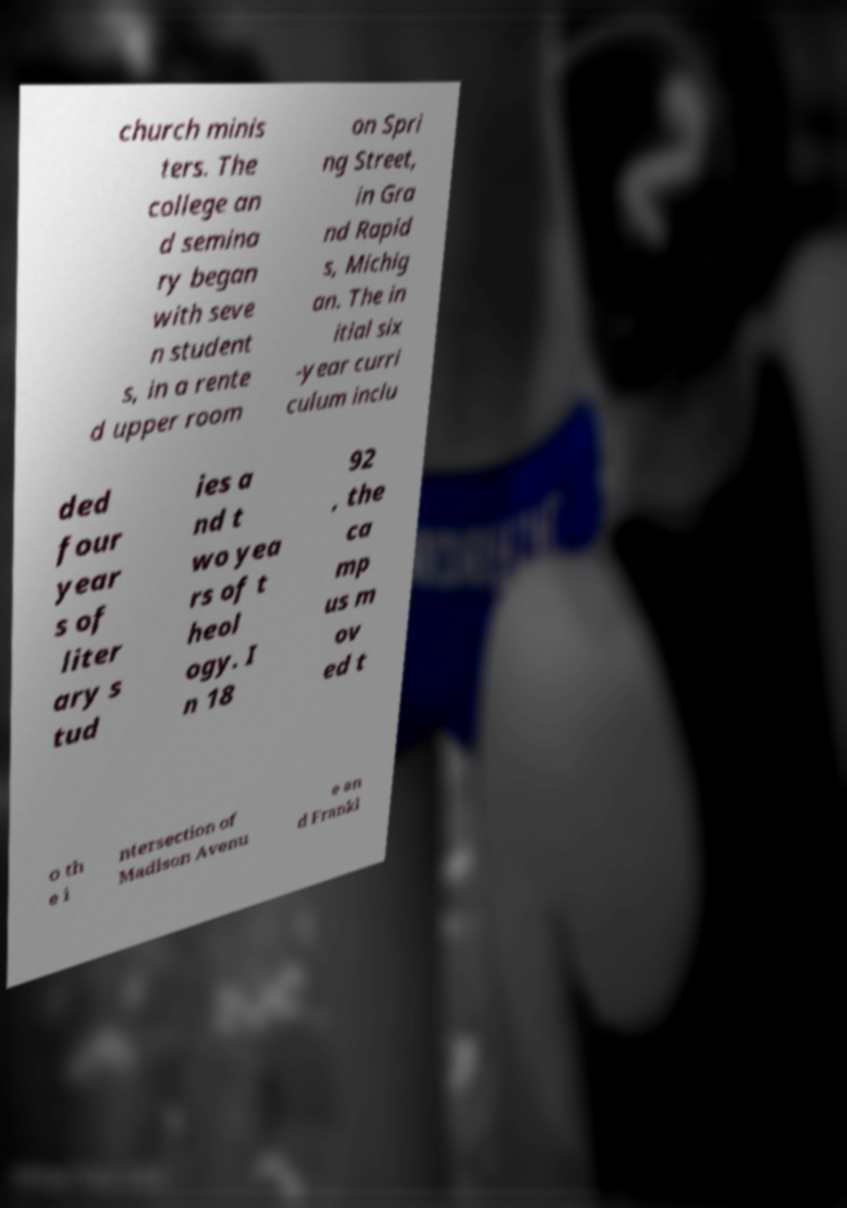Please read and relay the text visible in this image. What does it say? church minis ters. The college an d semina ry began with seve n student s, in a rente d upper room on Spri ng Street, in Gra nd Rapid s, Michig an. The in itial six -year curri culum inclu ded four year s of liter ary s tud ies a nd t wo yea rs of t heol ogy. I n 18 92 , the ca mp us m ov ed t o th e i ntersection of Madison Avenu e an d Frankl 